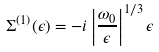Convert formula to latex. <formula><loc_0><loc_0><loc_500><loc_500>\Sigma ^ { ( 1 ) } ( \epsilon ) = - i \left | \frac { \omega _ { 0 } } { \epsilon } \right | ^ { 1 / 3 } \epsilon</formula> 